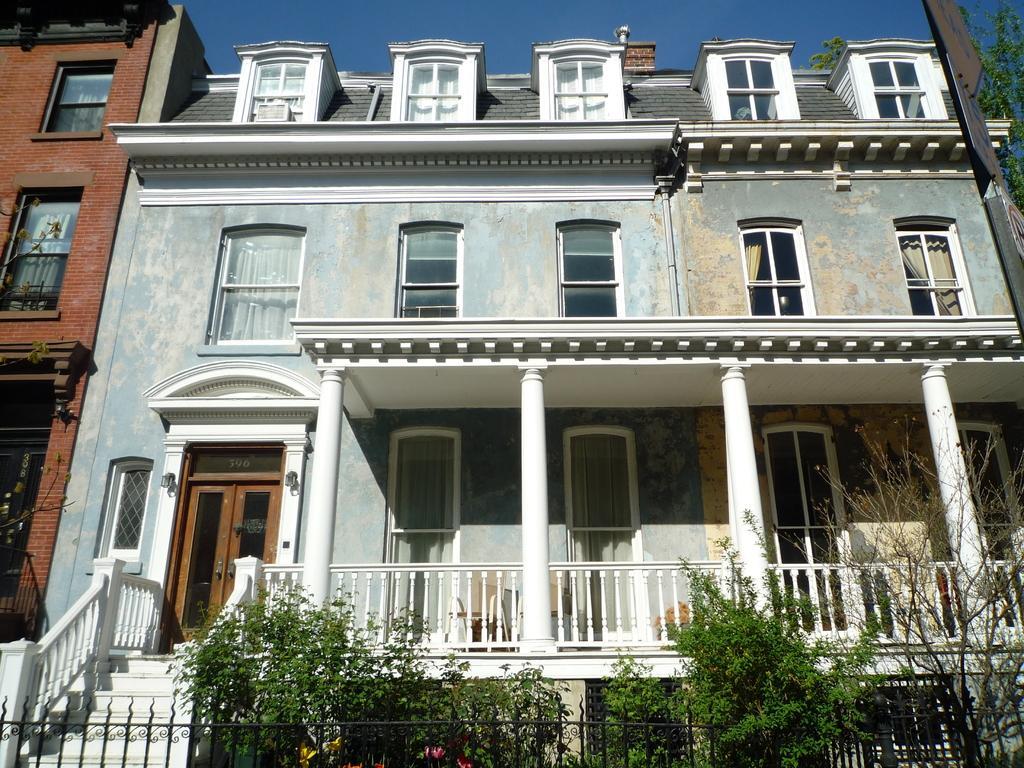Describe this image in one or two sentences. At the bottom there are trees, this is a building, at the top it is the sky. 